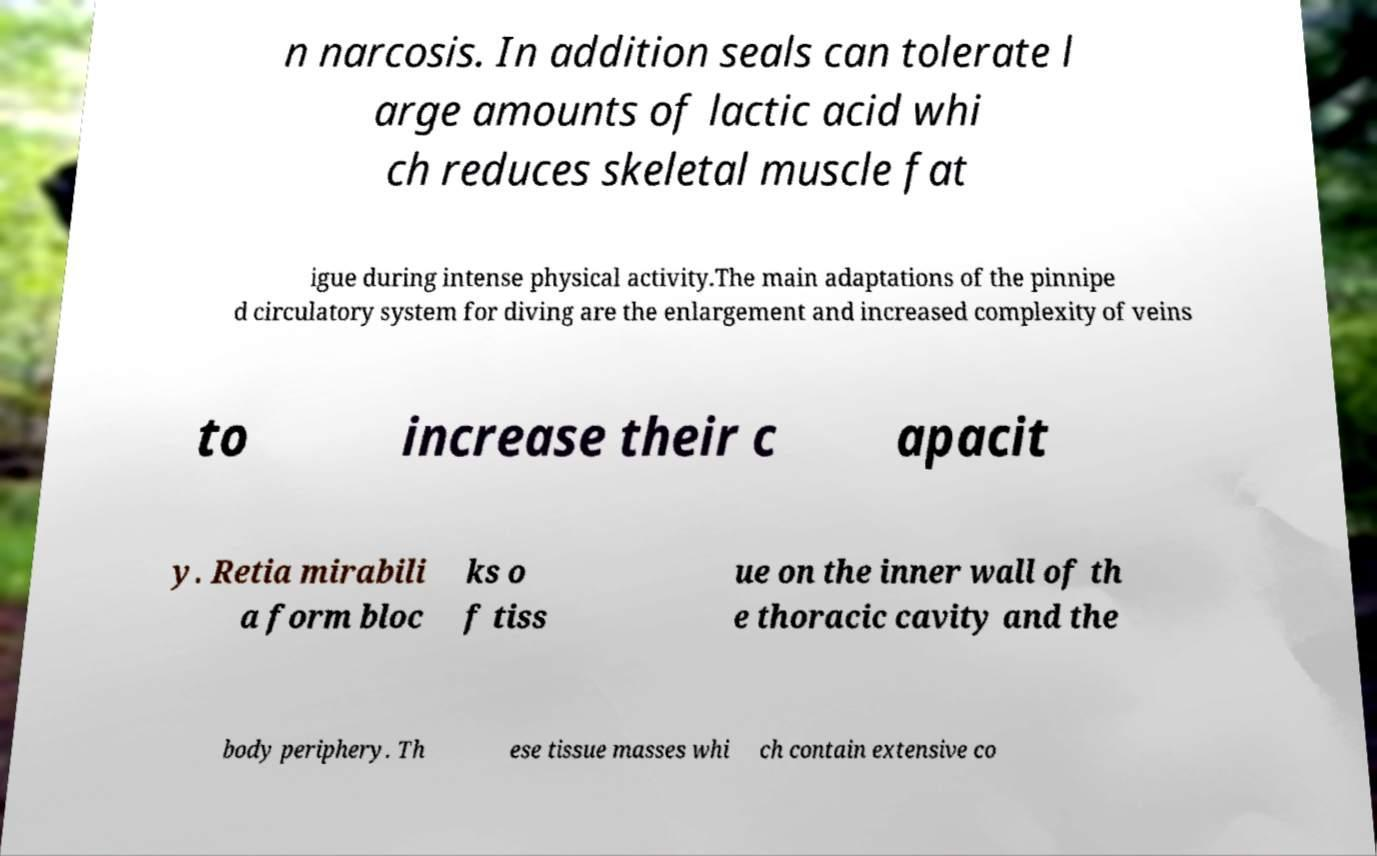What messages or text are displayed in this image? I need them in a readable, typed format. n narcosis. In addition seals can tolerate l arge amounts of lactic acid whi ch reduces skeletal muscle fat igue during intense physical activity.The main adaptations of the pinnipe d circulatory system for diving are the enlargement and increased complexity of veins to increase their c apacit y. Retia mirabili a form bloc ks o f tiss ue on the inner wall of th e thoracic cavity and the body periphery. Th ese tissue masses whi ch contain extensive co 